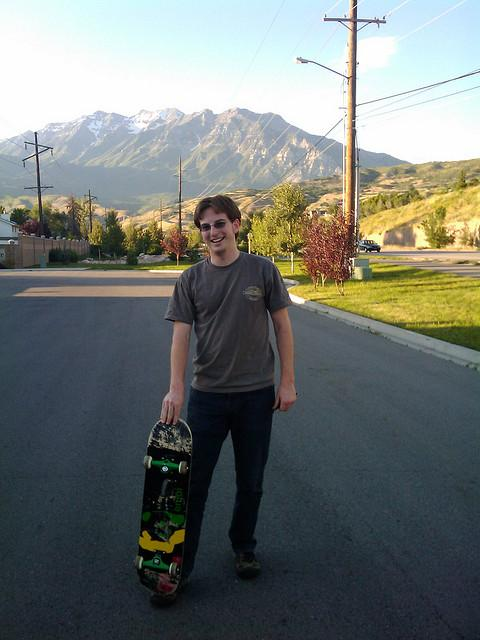What setting does the boarder pose in here? Please explain your reasoning. suburban. The setting is suburban. 